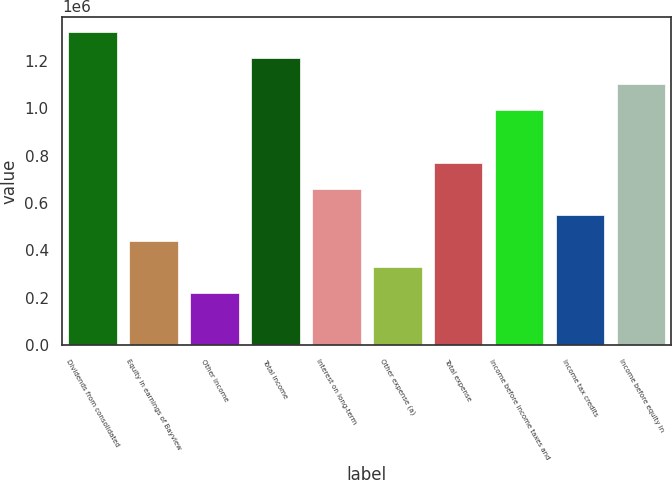Convert chart to OTSL. <chart><loc_0><loc_0><loc_500><loc_500><bar_chart><fcel>Dividends from consolidated<fcel>Equity in earnings of Bayview<fcel>Other income<fcel>Total income<fcel>Interest on long-term<fcel>Other expense (a)<fcel>Total expense<fcel>Income before income taxes and<fcel>Income tax credits<fcel>Income before equity in<nl><fcel>1.32074e+06<fcel>440251<fcel>220129<fcel>1.21068e+06<fcel>660373<fcel>330190<fcel>770434<fcel>990556<fcel>550312<fcel>1.10062e+06<nl></chart> 